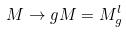Convert formula to latex. <formula><loc_0><loc_0><loc_500><loc_500>M \rightarrow g M = M _ { g } ^ { l }</formula> 